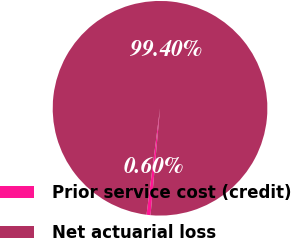Convert chart. <chart><loc_0><loc_0><loc_500><loc_500><pie_chart><fcel>Prior service cost (credit)<fcel>Net actuarial loss<nl><fcel>0.6%<fcel>99.4%<nl></chart> 